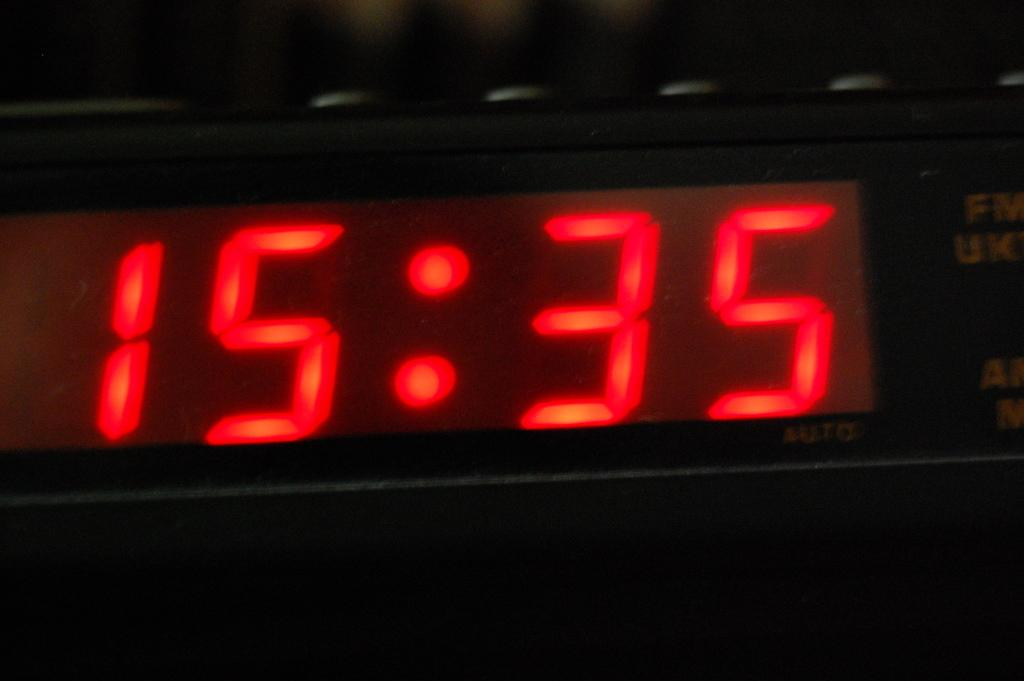Provide a one-sentence caption for the provided image. the alarm clock is saying that the time is 15:35. 